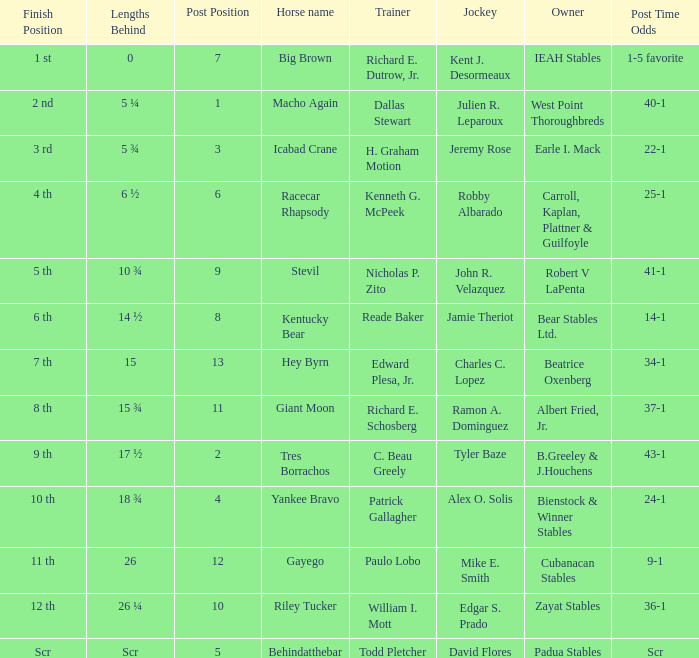Could you help me parse every detail presented in this table? {'header': ['Finish Position', 'Lengths Behind', 'Post Position', 'Horse name', 'Trainer', 'Jockey', 'Owner', 'Post Time Odds'], 'rows': [['1 st', '0', '7', 'Big Brown', 'Richard E. Dutrow, Jr.', 'Kent J. Desormeaux', 'IEAH Stables', '1-5 favorite'], ['2 nd', '5 ¼', '1', 'Macho Again', 'Dallas Stewart', 'Julien R. Leparoux', 'West Point Thoroughbreds', '40-1'], ['3 rd', '5 ¾', '3', 'Icabad Crane', 'H. Graham Motion', 'Jeremy Rose', 'Earle I. Mack', '22-1'], ['4 th', '6 ½', '6', 'Racecar Rhapsody', 'Kenneth G. McPeek', 'Robby Albarado', 'Carroll, Kaplan, Plattner & Guilfoyle', '25-1'], ['5 th', '10 ¾', '9', 'Stevil', 'Nicholas P. Zito', 'John R. Velazquez', 'Robert V LaPenta', '41-1'], ['6 th', '14 ½', '8', 'Kentucky Bear', 'Reade Baker', 'Jamie Theriot', 'Bear Stables Ltd.', '14-1'], ['7 th', '15', '13', 'Hey Byrn', 'Edward Plesa, Jr.', 'Charles C. Lopez', 'Beatrice Oxenberg', '34-1'], ['8 th', '15 ¾', '11', 'Giant Moon', 'Richard E. Schosberg', 'Ramon A. Dominguez', 'Albert Fried, Jr.', '37-1'], ['9 th', '17 ½', '2', 'Tres Borrachos', 'C. Beau Greely', 'Tyler Baze', 'B.Greeley & J.Houchens', '43-1'], ['10 th', '18 ¾', '4', 'Yankee Bravo', 'Patrick Gallagher', 'Alex O. Solis', 'Bienstock & Winner Stables', '24-1'], ['11 th', '26', '12', 'Gayego', 'Paulo Lobo', 'Mike E. Smith', 'Cubanacan Stables', '9-1'], ['12 th', '26 ¼', '10', 'Riley Tucker', 'William I. Mott', 'Edgar S. Prado', 'Zayat Stables', '36-1'], ['Scr', 'Scr', '5', 'Behindatthebar', 'Todd Pletcher', 'David Flores', 'Padua Stables', 'Scr']]} What's the post position when the lengths behind is 0? 7.0. 